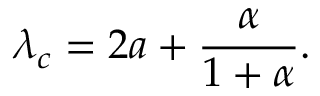Convert formula to latex. <formula><loc_0><loc_0><loc_500><loc_500>\lambda _ { c } = 2 a + \frac { \alpha } { 1 + \alpha } .</formula> 